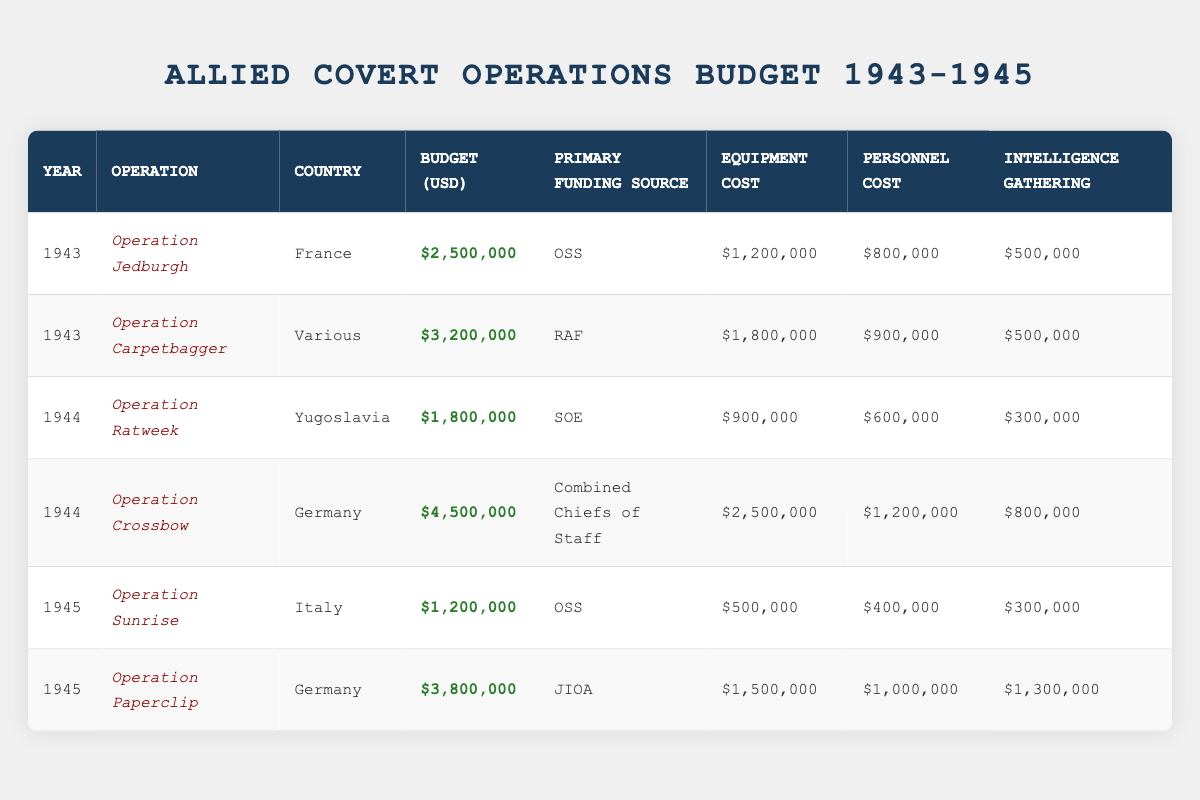What was the total budget allocated for Operation Crossbow? The budget for Operation Crossbow is listed as 4,500,000 USD in the table.
Answer: 4,500,000 USD In which country did Operation Ratweek take place? According to the table, Operation Ratweek occurred in Yugoslavia.
Answer: Yugoslavia What was the combined cost of equipment and personnel for Operation Paperclip? Operation Paperclip had equipment costs of 1,500,000 USD and personnel costs of 1,000,000 USD. Adding these gives 1,500,000 + 1,000,000 = 2,500,000 USD.
Answer: 2,500,000 USD Did the OSS provide funding for any operations in 1945? Yes, according to the table, the OSS funded Operation Sunrise in 1945.
Answer: Yes What is the average budget for all operations listed in the table? To find the average budget, we first sum all budgets: 2,500,000 + 3,200,000 + 1,800,000 + 4,500,000 + 1,200,000 + 3,800,000 = 17,000,000 USD. There are 6 operations, so the average is 17,000,000 / 6 ≈ 2,833,333 USD.
Answer: 2,833,333 USD Which operation had the highest equipment cost, and what was that cost? Looking through the equipment costs, Operation Crossbow had the highest cost of 2,500,000 USD, making it the operation with the highest equipment budget.
Answer: Operation Crossbow, 2,500,000 USD What was the total amount allocated for intelligence gathering across all operations? The sums for intelligence gathering are: 500,000 + 500,000 + 300,000 + 800,000 + 300,000 + 1,300,000 = 2,700,000 USD totaling for all operations.
Answer: 2,700,000 USD Is it true that all operations in 1944 had budgets exceeding 1,500,000 USD? Yes, both Operation Ratweek and Operation Crossbow, the operations in 1944, had budgets of 1,800,000 USD and 4,500,000 USD respectively, both exceeding 1,500,000 USD.
Answer: Yes 